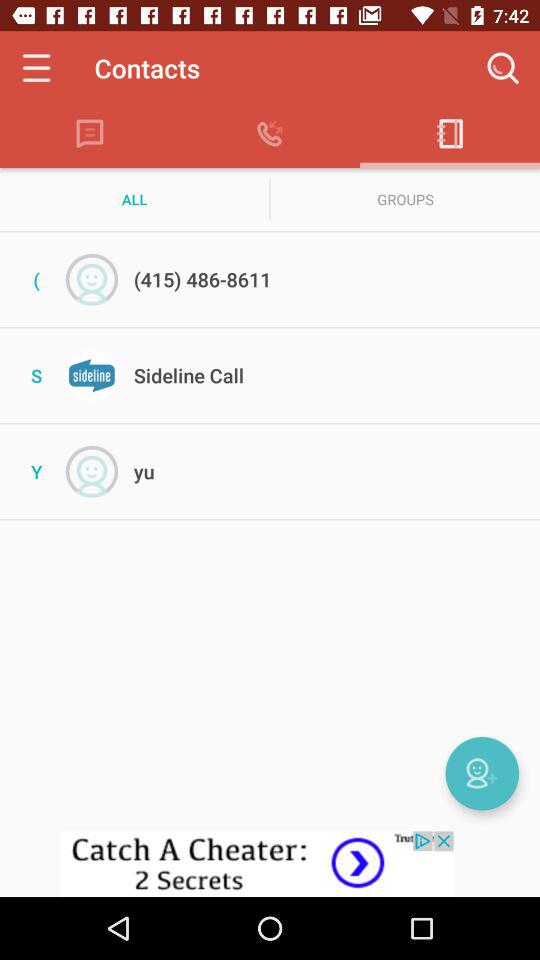Which option is selected in "Contacts"? The options selected in "Contacts" are "Phone book" and "ALL". 